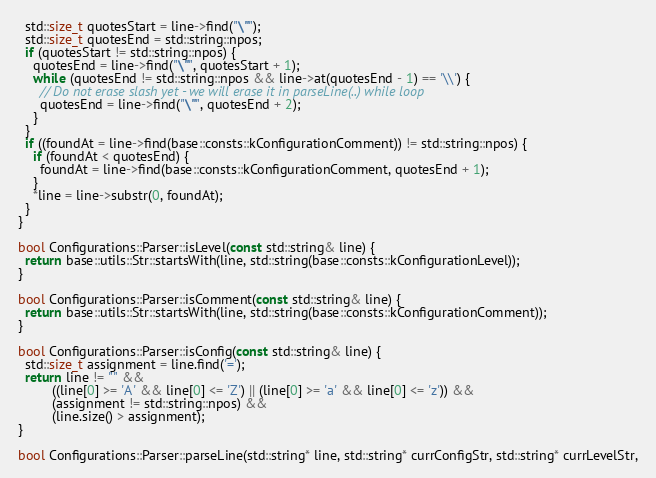<code> <loc_0><loc_0><loc_500><loc_500><_C++_>  std::size_t quotesStart = line->find("\"");
  std::size_t quotesEnd = std::string::npos;
  if (quotesStart != std::string::npos) {
    quotesEnd = line->find("\"", quotesStart + 1);
    while (quotesEnd != std::string::npos && line->at(quotesEnd - 1) == '\\') {
      // Do not erase slash yet - we will erase it in parseLine(..) while loop
      quotesEnd = line->find("\"", quotesEnd + 2);
    }
  }
  if ((foundAt = line->find(base::consts::kConfigurationComment)) != std::string::npos) {
    if (foundAt < quotesEnd) {
      foundAt = line->find(base::consts::kConfigurationComment, quotesEnd + 1);
    }
    *line = line->substr(0, foundAt);
  }
}

bool Configurations::Parser::isLevel(const std::string& line) {
  return base::utils::Str::startsWith(line, std::string(base::consts::kConfigurationLevel));
}

bool Configurations::Parser::isComment(const std::string& line) {
  return base::utils::Str::startsWith(line, std::string(base::consts::kConfigurationComment));
}

bool Configurations::Parser::isConfig(const std::string& line) {
  std::size_t assignment = line.find('=');
  return line != "" &&
         ((line[0] >= 'A' && line[0] <= 'Z') || (line[0] >= 'a' && line[0] <= 'z')) &&
         (assignment != std::string::npos) &&
         (line.size() > assignment);
}

bool Configurations::Parser::parseLine(std::string* line, std::string* currConfigStr, std::string* currLevelStr,</code> 